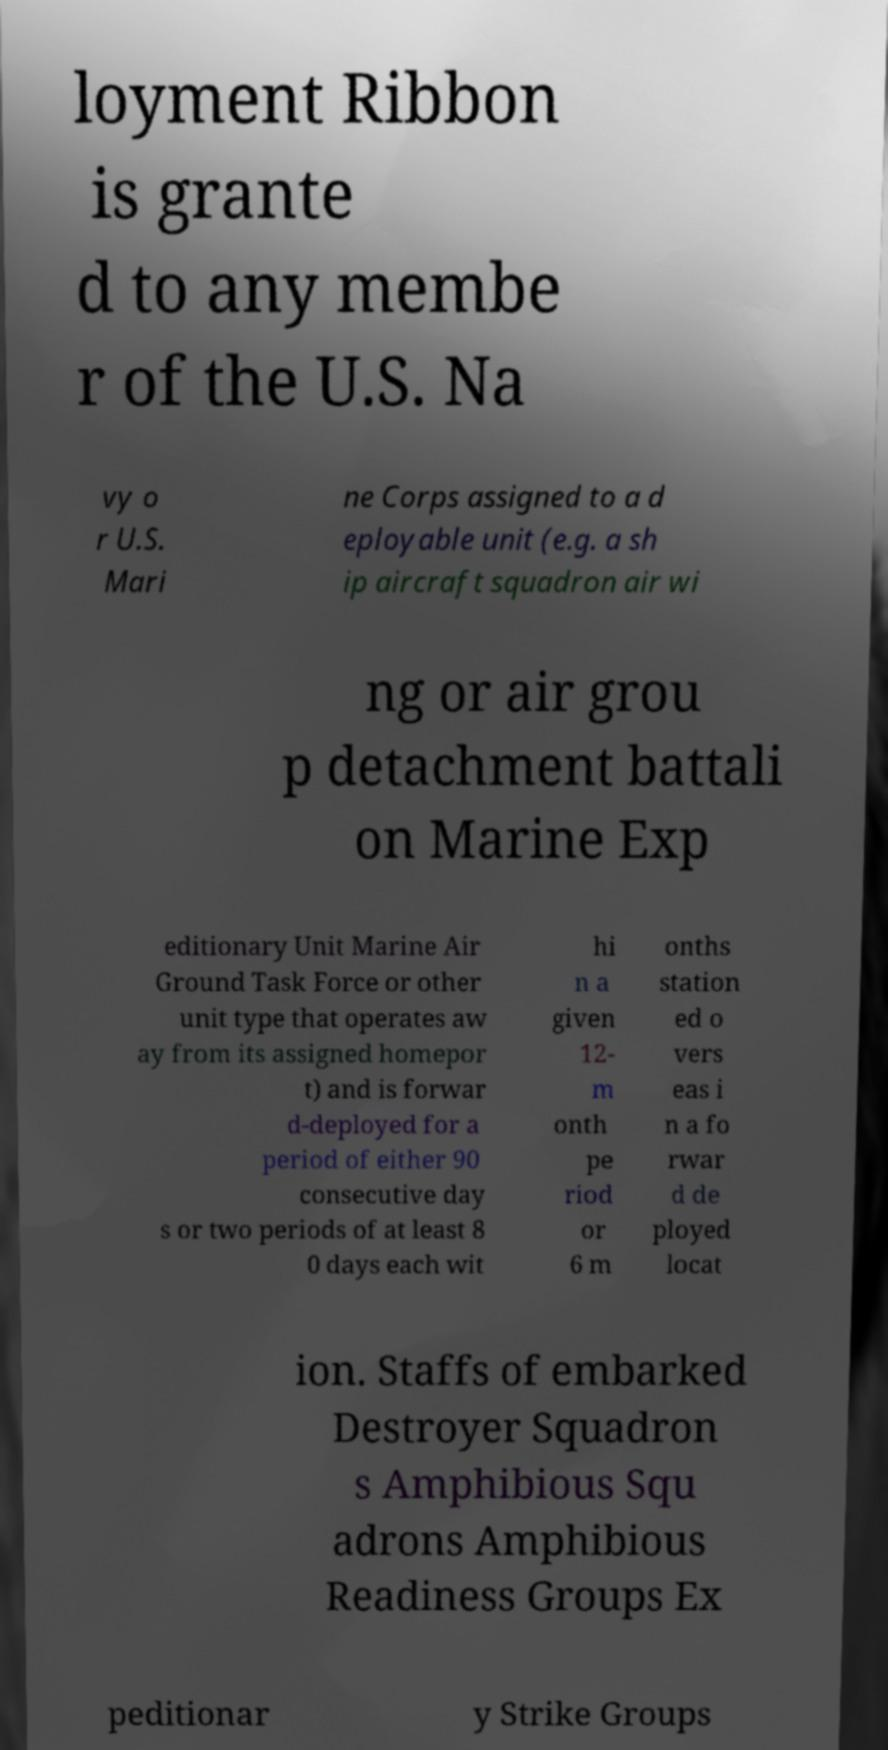There's text embedded in this image that I need extracted. Can you transcribe it verbatim? loyment Ribbon is grante d to any membe r of the U.S. Na vy o r U.S. Mari ne Corps assigned to a d eployable unit (e.g. a sh ip aircraft squadron air wi ng or air grou p detachment battali on Marine Exp editionary Unit Marine Air Ground Task Force or other unit type that operates aw ay from its assigned homepor t) and is forwar d-deployed for a period of either 90 consecutive day s or two periods of at least 8 0 days each wit hi n a given 12- m onth pe riod or 6 m onths station ed o vers eas i n a fo rwar d de ployed locat ion. Staffs of embarked Destroyer Squadron s Amphibious Squ adrons Amphibious Readiness Groups Ex peditionar y Strike Groups 